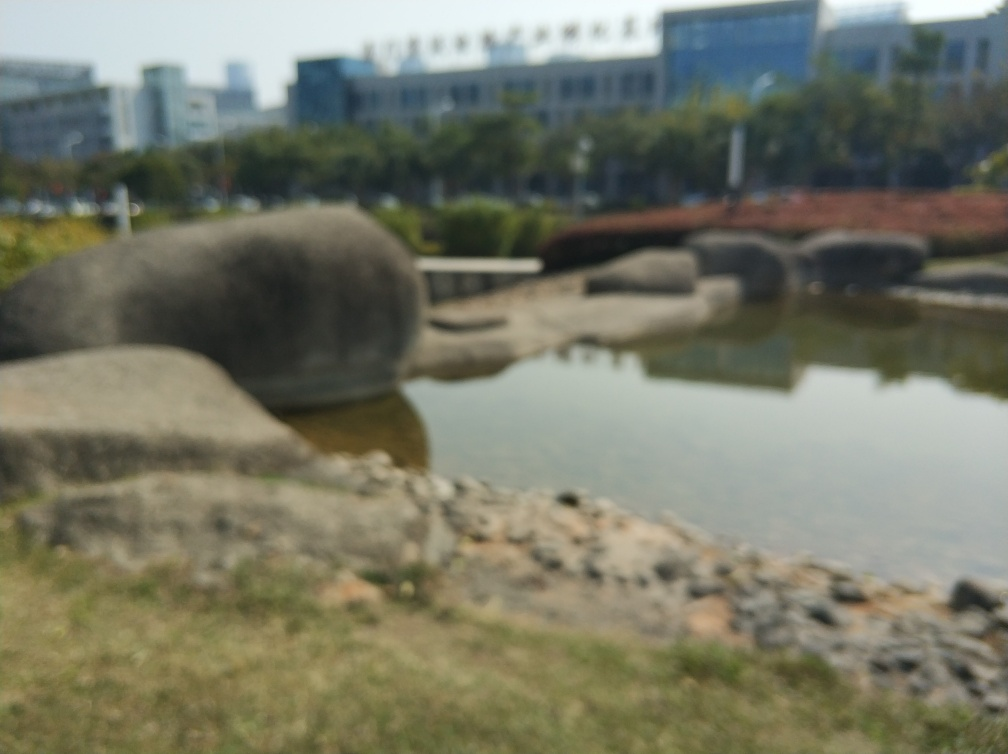Is there any activity indicated in this image? The blurriness of the image makes it difficult to detect any distinct activity. However, there aren't any obvious signs of movement or people that can be clearly identified. It appears to be a tranquil scene without noticeable action. 